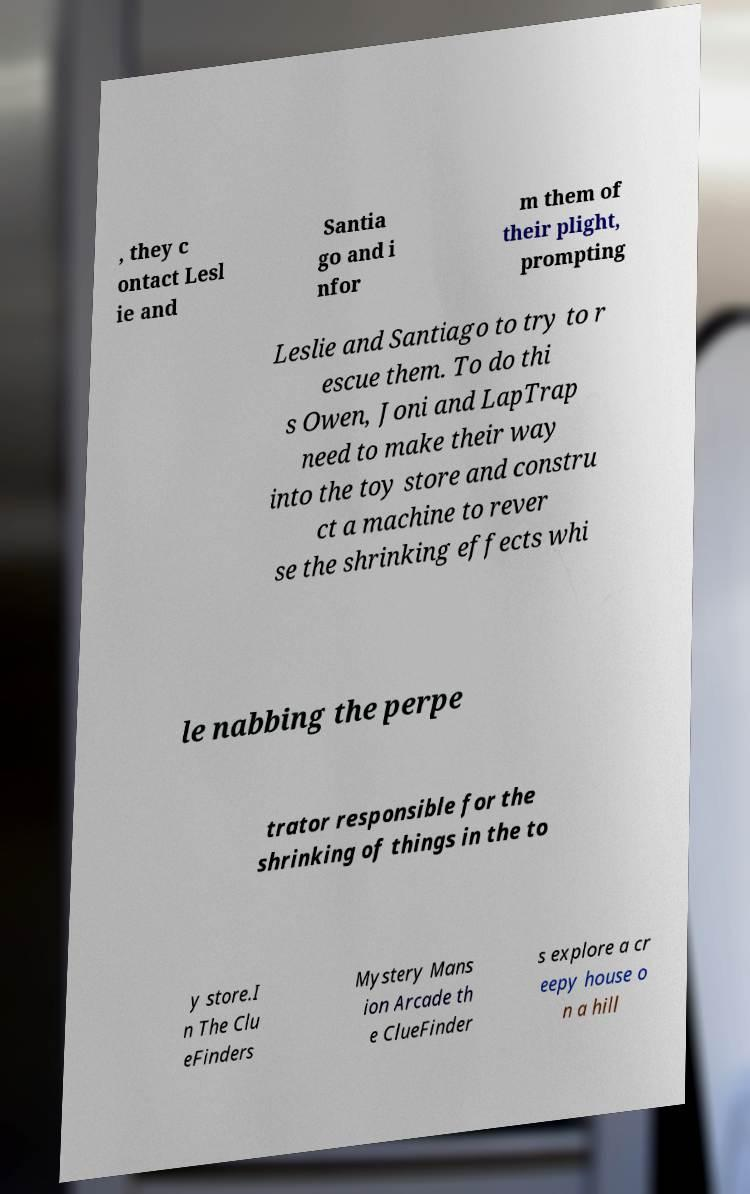Could you extract and type out the text from this image? , they c ontact Lesl ie and Santia go and i nfor m them of their plight, prompting Leslie and Santiago to try to r escue them. To do thi s Owen, Joni and LapTrap need to make their way into the toy store and constru ct a machine to rever se the shrinking effects whi le nabbing the perpe trator responsible for the shrinking of things in the to y store.I n The Clu eFinders Mystery Mans ion Arcade th e ClueFinder s explore a cr eepy house o n a hill 